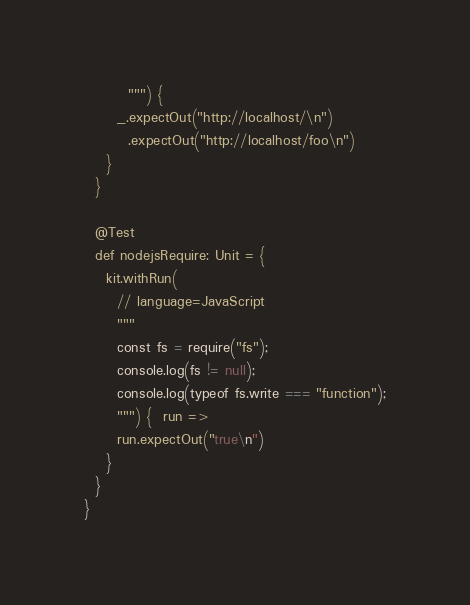<code> <loc_0><loc_0><loc_500><loc_500><_Scala_>        """) {
      _.expectOut("http://localhost/\n")
        .expectOut("http://localhost/foo\n")
    }
  }

  @Test
  def nodejsRequire: Unit = {
    kit.withRun(
      // language=JavaScript
      """
      const fs = require("fs");
      console.log(fs != null);
      console.log(typeof fs.write === "function");
      """) {  run =>
      run.expectOut("true\n")
    }
  }
}
</code> 